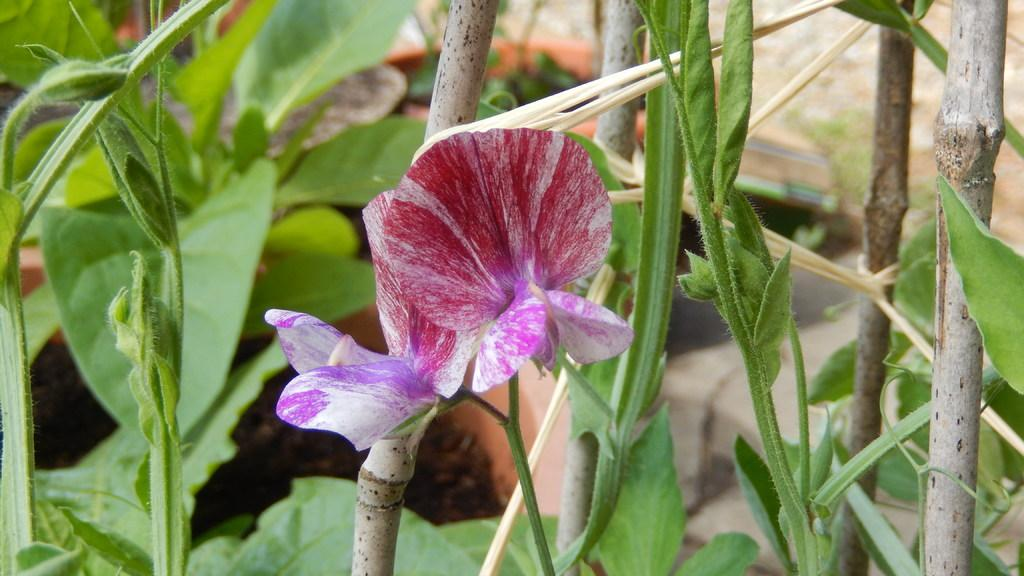What type of living organisms can be seen in the image? There are flowers and plants in the image. Can you describe the plants in the image? The plants in the image are not specified, but they are present alongside the flowers. What type of clover is growing in the image? There is no clover present in the image; it only features flowers and plants. What type of vessel is being used to water the plants in the image? There is no vessel visible in the image, as it only shows flowers and plants. 